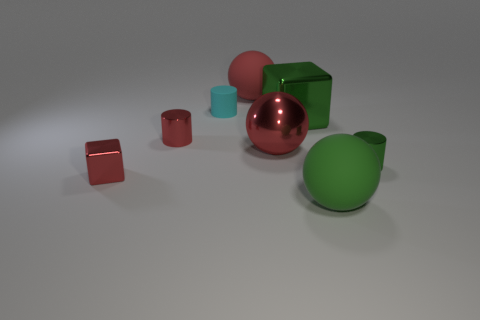How many tiny shiny objects have the same color as the small matte cylinder?
Give a very brief answer. 0. There is a matte thing that is the same size as the red matte sphere; what shape is it?
Your answer should be very brief. Sphere. Are there any other things that have the same shape as the red rubber object?
Provide a succinct answer. Yes. What number of tiny red blocks are made of the same material as the tiny cyan cylinder?
Give a very brief answer. 0. Does the red sphere behind the cyan rubber cylinder have the same material as the cyan cylinder?
Give a very brief answer. Yes. Is the number of tiny red shiny objects that are behind the small cyan thing greater than the number of tiny green things that are left of the tiny green shiny thing?
Ensure brevity in your answer.  No. There is a green sphere that is the same size as the green shiny block; what material is it?
Your answer should be compact. Rubber. How many other objects are there of the same material as the green block?
Give a very brief answer. 4. Do the big matte object that is behind the cyan cylinder and the tiny thing behind the red metal cylinder have the same shape?
Give a very brief answer. No. What number of other things are the same color as the small cube?
Your answer should be compact. 3. 